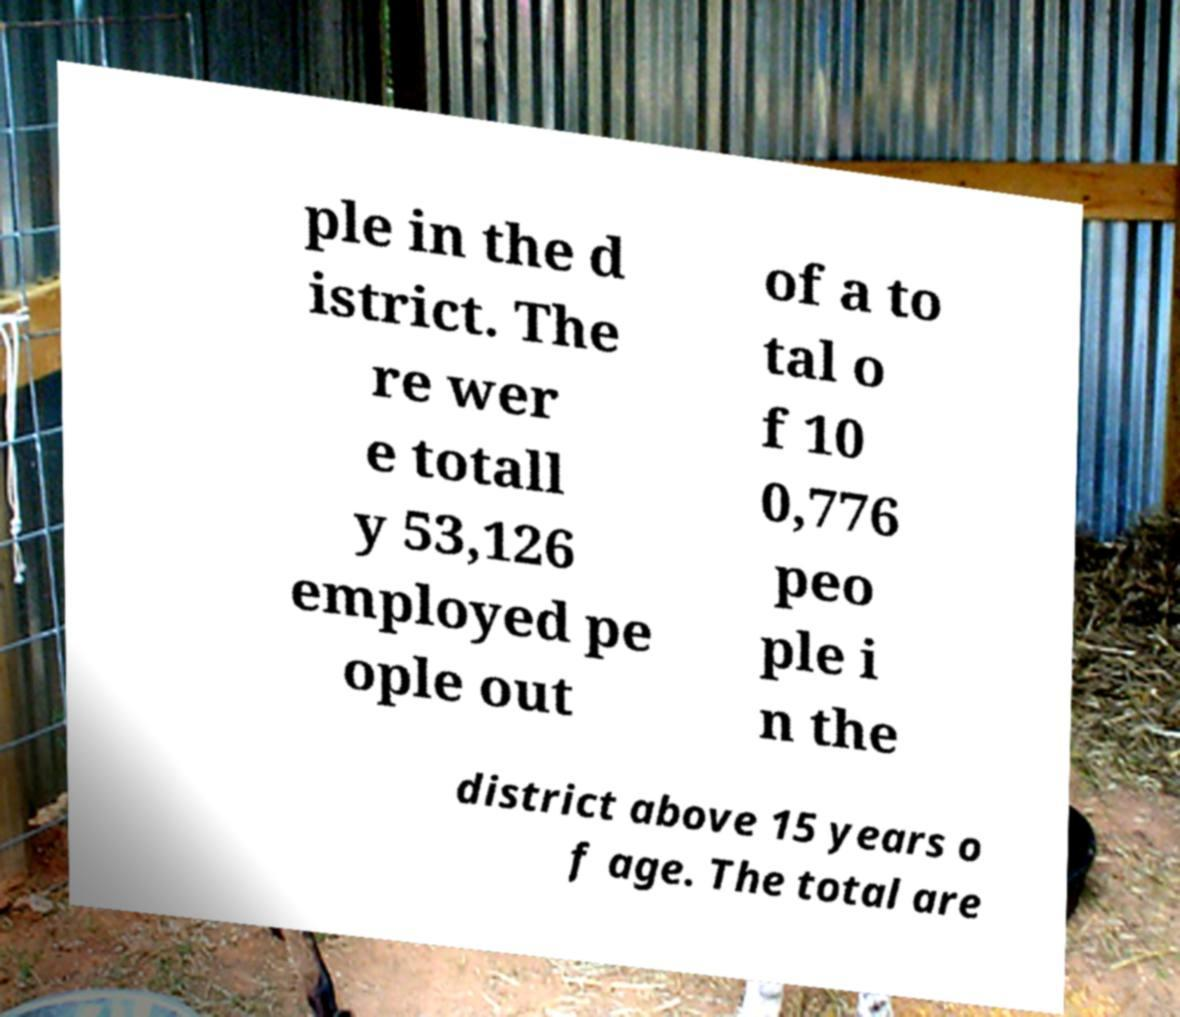There's text embedded in this image that I need extracted. Can you transcribe it verbatim? ple in the d istrict. The re wer e totall y 53,126 employed pe ople out of a to tal o f 10 0,776 peo ple i n the district above 15 years o f age. The total are 